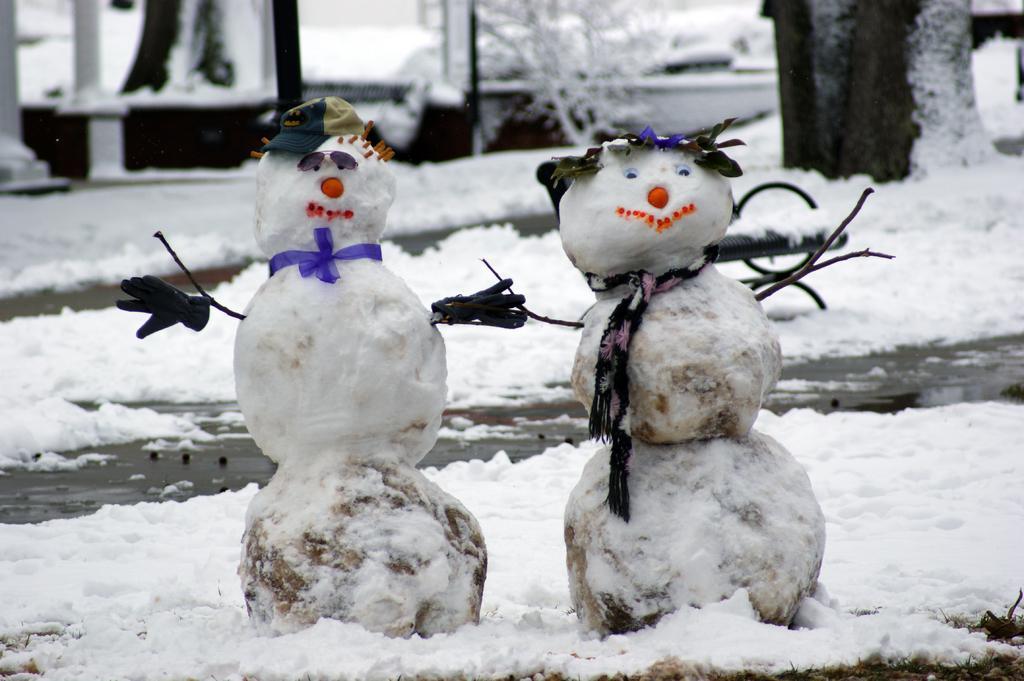Please provide a concise description of this image. In the center of the image we can see snow mans. In the background there are trees covered by snow. At the bottom there is snow. 